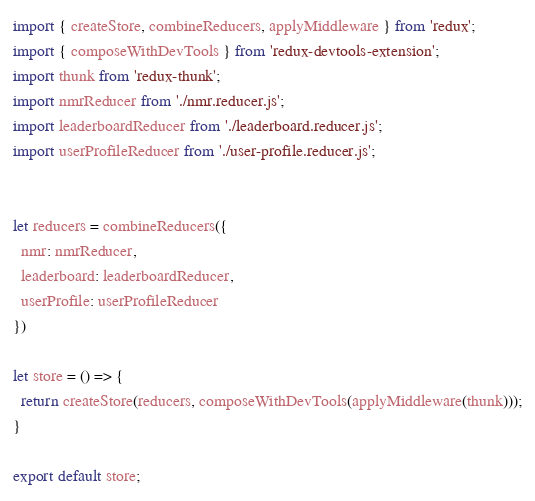Convert code to text. <code><loc_0><loc_0><loc_500><loc_500><_JavaScript_>import { createStore, combineReducers, applyMiddleware } from 'redux';
import { composeWithDevTools } from 'redux-devtools-extension';
import thunk from 'redux-thunk';
import nmrReducer from './nmr.reducer.js';
import leaderboardReducer from './leaderboard.reducer.js';
import userProfileReducer from './user-profile.reducer.js';


let reducers = combineReducers({
  nmr: nmrReducer,
  leaderboard: leaderboardReducer,
  userProfile: userProfileReducer
})

let store = () => {
  return createStore(reducers, composeWithDevTools(applyMiddleware(thunk)));
}

export default store;</code> 